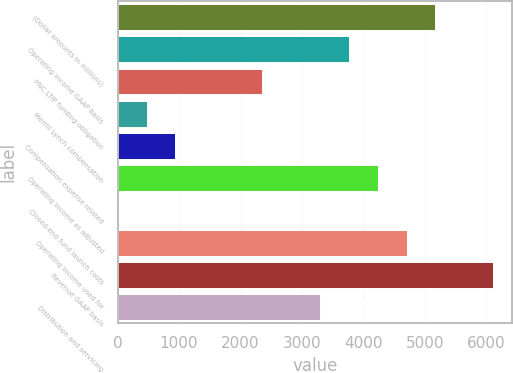Convert chart. <chart><loc_0><loc_0><loc_500><loc_500><bar_chart><fcel>(Dollar amounts in millions)<fcel>Operating income GAAP basis<fcel>PNC LTIP funding obligation<fcel>Merrill Lynch compensation<fcel>Compensation expense related<fcel>Operating income as adjusted<fcel>Closed-end fund launch costs<fcel>Operating income used for<fcel>Revenue GAAP basis<fcel>Distribution and servicing<nl><fcel>5169.8<fcel>3760.4<fcel>2351<fcel>471.8<fcel>941.6<fcel>4230.2<fcel>2<fcel>4700<fcel>6109.4<fcel>3290.6<nl></chart> 